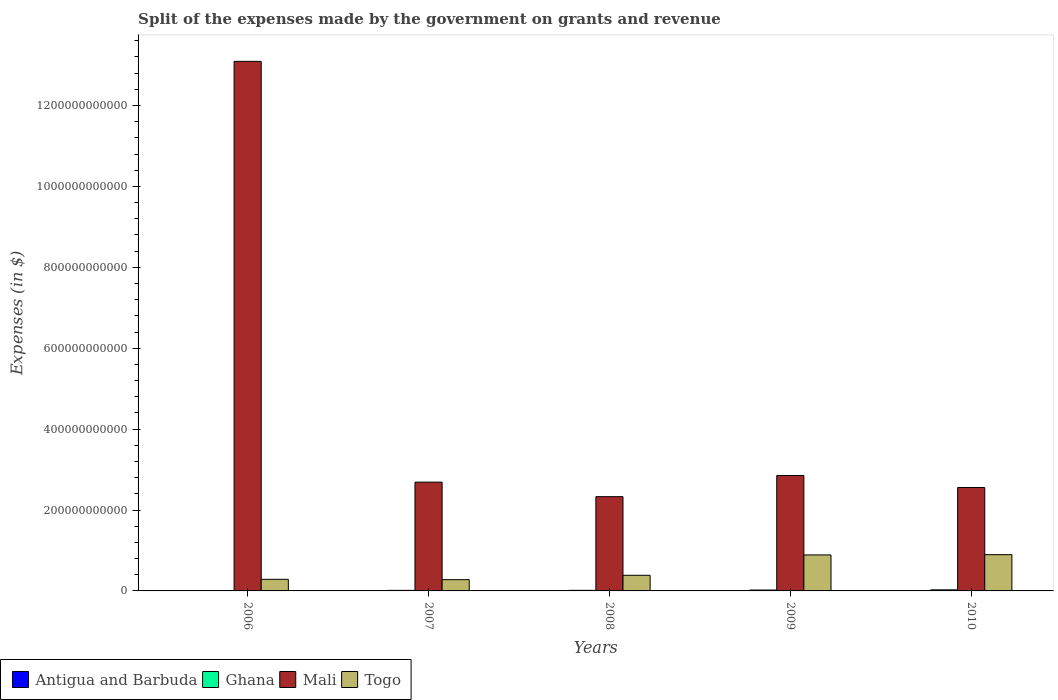Are the number of bars on each tick of the X-axis equal?
Provide a succinct answer. Yes. What is the label of the 3rd group of bars from the left?
Keep it short and to the point. 2008. In how many cases, is the number of bars for a given year not equal to the number of legend labels?
Provide a short and direct response. 0. What is the expenses made by the government on grants and revenue in Mali in 2006?
Your answer should be very brief. 1.31e+12. Across all years, what is the maximum expenses made by the government on grants and revenue in Antigua and Barbuda?
Your answer should be very brief. 1.10e+08. Across all years, what is the minimum expenses made by the government on grants and revenue in Ghana?
Make the answer very short. 8.75e+08. In which year was the expenses made by the government on grants and revenue in Mali maximum?
Provide a short and direct response. 2006. In which year was the expenses made by the government on grants and revenue in Ghana minimum?
Ensure brevity in your answer.  2006. What is the total expenses made by the government on grants and revenue in Ghana in the graph?
Provide a succinct answer. 8.56e+09. What is the difference between the expenses made by the government on grants and revenue in Mali in 2006 and that in 2007?
Make the answer very short. 1.04e+12. What is the difference between the expenses made by the government on grants and revenue in Antigua and Barbuda in 2010 and the expenses made by the government on grants and revenue in Ghana in 2006?
Your answer should be very brief. -7.67e+08. What is the average expenses made by the government on grants and revenue in Ghana per year?
Ensure brevity in your answer.  1.71e+09. In the year 2010, what is the difference between the expenses made by the government on grants and revenue in Ghana and expenses made by the government on grants and revenue in Antigua and Barbuda?
Keep it short and to the point. 2.59e+09. What is the ratio of the expenses made by the government on grants and revenue in Ghana in 2008 to that in 2010?
Keep it short and to the point. 0.53. Is the difference between the expenses made by the government on grants and revenue in Ghana in 2006 and 2010 greater than the difference between the expenses made by the government on grants and revenue in Antigua and Barbuda in 2006 and 2010?
Keep it short and to the point. No. What is the difference between the highest and the second highest expenses made by the government on grants and revenue in Antigua and Barbuda?
Give a very brief answer. 2.40e+06. What is the difference between the highest and the lowest expenses made by the government on grants and revenue in Ghana?
Your answer should be compact. 1.82e+09. Is the sum of the expenses made by the government on grants and revenue in Togo in 2008 and 2010 greater than the maximum expenses made by the government on grants and revenue in Ghana across all years?
Your answer should be compact. Yes. Is it the case that in every year, the sum of the expenses made by the government on grants and revenue in Ghana and expenses made by the government on grants and revenue in Antigua and Barbuda is greater than the sum of expenses made by the government on grants and revenue in Mali and expenses made by the government on grants and revenue in Togo?
Provide a succinct answer. Yes. What does the 3rd bar from the left in 2006 represents?
Your answer should be compact. Mali. What does the 4th bar from the right in 2010 represents?
Provide a short and direct response. Antigua and Barbuda. Is it the case that in every year, the sum of the expenses made by the government on grants and revenue in Togo and expenses made by the government on grants and revenue in Ghana is greater than the expenses made by the government on grants and revenue in Antigua and Barbuda?
Give a very brief answer. Yes. How many bars are there?
Keep it short and to the point. 20. How many years are there in the graph?
Provide a succinct answer. 5. What is the difference between two consecutive major ticks on the Y-axis?
Keep it short and to the point. 2.00e+11. Does the graph contain any zero values?
Your answer should be compact. No. Where does the legend appear in the graph?
Provide a short and direct response. Bottom left. How are the legend labels stacked?
Your response must be concise. Horizontal. What is the title of the graph?
Provide a succinct answer. Split of the expenses made by the government on grants and revenue. What is the label or title of the Y-axis?
Give a very brief answer. Expenses (in $). What is the Expenses (in $) of Antigua and Barbuda in 2006?
Offer a terse response. 1.10e+08. What is the Expenses (in $) of Ghana in 2006?
Offer a very short reply. 8.75e+08. What is the Expenses (in $) in Mali in 2006?
Your answer should be very brief. 1.31e+12. What is the Expenses (in $) in Togo in 2006?
Keep it short and to the point. 2.87e+1. What is the Expenses (in $) of Antigua and Barbuda in 2007?
Your answer should be very brief. 5.38e+07. What is the Expenses (in $) of Ghana in 2007?
Offer a terse response. 1.36e+09. What is the Expenses (in $) of Mali in 2007?
Make the answer very short. 2.69e+11. What is the Expenses (in $) of Togo in 2007?
Your answer should be compact. 2.78e+1. What is the Expenses (in $) in Antigua and Barbuda in 2008?
Provide a succinct answer. 7.36e+07. What is the Expenses (in $) of Ghana in 2008?
Provide a succinct answer. 1.44e+09. What is the Expenses (in $) in Mali in 2008?
Offer a very short reply. 2.33e+11. What is the Expenses (in $) in Togo in 2008?
Offer a terse response. 3.87e+1. What is the Expenses (in $) of Antigua and Barbuda in 2009?
Provide a succinct answer. 2.25e+07. What is the Expenses (in $) in Ghana in 2009?
Give a very brief answer. 2.19e+09. What is the Expenses (in $) in Mali in 2009?
Your response must be concise. 2.85e+11. What is the Expenses (in $) of Togo in 2009?
Your answer should be very brief. 8.90e+1. What is the Expenses (in $) in Antigua and Barbuda in 2010?
Make the answer very short. 1.08e+08. What is the Expenses (in $) of Ghana in 2010?
Provide a succinct answer. 2.69e+09. What is the Expenses (in $) in Mali in 2010?
Your answer should be compact. 2.56e+11. What is the Expenses (in $) of Togo in 2010?
Keep it short and to the point. 8.96e+1. Across all years, what is the maximum Expenses (in $) in Antigua and Barbuda?
Keep it short and to the point. 1.10e+08. Across all years, what is the maximum Expenses (in $) of Ghana?
Offer a very short reply. 2.69e+09. Across all years, what is the maximum Expenses (in $) of Mali?
Give a very brief answer. 1.31e+12. Across all years, what is the maximum Expenses (in $) of Togo?
Your response must be concise. 8.96e+1. Across all years, what is the minimum Expenses (in $) of Antigua and Barbuda?
Provide a short and direct response. 2.25e+07. Across all years, what is the minimum Expenses (in $) in Ghana?
Keep it short and to the point. 8.75e+08. Across all years, what is the minimum Expenses (in $) in Mali?
Your answer should be very brief. 2.33e+11. Across all years, what is the minimum Expenses (in $) in Togo?
Your answer should be very brief. 2.78e+1. What is the total Expenses (in $) of Antigua and Barbuda in the graph?
Provide a succinct answer. 3.68e+08. What is the total Expenses (in $) of Ghana in the graph?
Offer a very short reply. 8.56e+09. What is the total Expenses (in $) in Mali in the graph?
Offer a terse response. 2.35e+12. What is the total Expenses (in $) in Togo in the graph?
Provide a short and direct response. 2.74e+11. What is the difference between the Expenses (in $) of Antigua and Barbuda in 2006 and that in 2007?
Provide a short and direct response. 5.66e+07. What is the difference between the Expenses (in $) in Ghana in 2006 and that in 2007?
Make the answer very short. -4.88e+08. What is the difference between the Expenses (in $) of Mali in 2006 and that in 2007?
Offer a terse response. 1.04e+12. What is the difference between the Expenses (in $) of Togo in 2006 and that in 2007?
Offer a terse response. 8.62e+08. What is the difference between the Expenses (in $) in Antigua and Barbuda in 2006 and that in 2008?
Offer a terse response. 3.68e+07. What is the difference between the Expenses (in $) in Ghana in 2006 and that in 2008?
Give a very brief answer. -5.66e+08. What is the difference between the Expenses (in $) of Mali in 2006 and that in 2008?
Your response must be concise. 1.08e+12. What is the difference between the Expenses (in $) of Togo in 2006 and that in 2008?
Your response must be concise. -9.99e+09. What is the difference between the Expenses (in $) of Antigua and Barbuda in 2006 and that in 2009?
Your answer should be compact. 8.79e+07. What is the difference between the Expenses (in $) in Ghana in 2006 and that in 2009?
Provide a short and direct response. -1.31e+09. What is the difference between the Expenses (in $) in Mali in 2006 and that in 2009?
Ensure brevity in your answer.  1.02e+12. What is the difference between the Expenses (in $) of Togo in 2006 and that in 2009?
Provide a succinct answer. -6.03e+1. What is the difference between the Expenses (in $) of Antigua and Barbuda in 2006 and that in 2010?
Ensure brevity in your answer.  2.40e+06. What is the difference between the Expenses (in $) in Ghana in 2006 and that in 2010?
Your answer should be very brief. -1.82e+09. What is the difference between the Expenses (in $) in Mali in 2006 and that in 2010?
Your answer should be compact. 1.05e+12. What is the difference between the Expenses (in $) in Togo in 2006 and that in 2010?
Your answer should be compact. -6.09e+1. What is the difference between the Expenses (in $) in Antigua and Barbuda in 2007 and that in 2008?
Give a very brief answer. -1.98e+07. What is the difference between the Expenses (in $) in Ghana in 2007 and that in 2008?
Your response must be concise. -7.78e+07. What is the difference between the Expenses (in $) of Mali in 2007 and that in 2008?
Make the answer very short. 3.59e+1. What is the difference between the Expenses (in $) in Togo in 2007 and that in 2008?
Your answer should be compact. -1.08e+1. What is the difference between the Expenses (in $) in Antigua and Barbuda in 2007 and that in 2009?
Offer a terse response. 3.13e+07. What is the difference between the Expenses (in $) of Ghana in 2007 and that in 2009?
Offer a very short reply. -8.24e+08. What is the difference between the Expenses (in $) in Mali in 2007 and that in 2009?
Offer a terse response. -1.63e+1. What is the difference between the Expenses (in $) in Togo in 2007 and that in 2009?
Make the answer very short. -6.11e+1. What is the difference between the Expenses (in $) in Antigua and Barbuda in 2007 and that in 2010?
Keep it short and to the point. -5.42e+07. What is the difference between the Expenses (in $) of Ghana in 2007 and that in 2010?
Give a very brief answer. -1.33e+09. What is the difference between the Expenses (in $) of Mali in 2007 and that in 2010?
Give a very brief answer. 1.32e+1. What is the difference between the Expenses (in $) of Togo in 2007 and that in 2010?
Offer a very short reply. -6.18e+1. What is the difference between the Expenses (in $) in Antigua and Barbuda in 2008 and that in 2009?
Provide a short and direct response. 5.11e+07. What is the difference between the Expenses (in $) in Ghana in 2008 and that in 2009?
Offer a very short reply. -7.46e+08. What is the difference between the Expenses (in $) in Mali in 2008 and that in 2009?
Offer a very short reply. -5.23e+1. What is the difference between the Expenses (in $) in Togo in 2008 and that in 2009?
Keep it short and to the point. -5.03e+1. What is the difference between the Expenses (in $) of Antigua and Barbuda in 2008 and that in 2010?
Your response must be concise. -3.44e+07. What is the difference between the Expenses (in $) of Ghana in 2008 and that in 2010?
Your answer should be compact. -1.25e+09. What is the difference between the Expenses (in $) of Mali in 2008 and that in 2010?
Offer a terse response. -2.27e+1. What is the difference between the Expenses (in $) in Togo in 2008 and that in 2010?
Offer a terse response. -5.10e+1. What is the difference between the Expenses (in $) in Antigua and Barbuda in 2009 and that in 2010?
Keep it short and to the point. -8.55e+07. What is the difference between the Expenses (in $) in Ghana in 2009 and that in 2010?
Offer a very short reply. -5.08e+08. What is the difference between the Expenses (in $) in Mali in 2009 and that in 2010?
Keep it short and to the point. 2.96e+1. What is the difference between the Expenses (in $) of Togo in 2009 and that in 2010?
Ensure brevity in your answer.  -6.60e+08. What is the difference between the Expenses (in $) in Antigua and Barbuda in 2006 and the Expenses (in $) in Ghana in 2007?
Your answer should be very brief. -1.25e+09. What is the difference between the Expenses (in $) of Antigua and Barbuda in 2006 and the Expenses (in $) of Mali in 2007?
Your response must be concise. -2.69e+11. What is the difference between the Expenses (in $) in Antigua and Barbuda in 2006 and the Expenses (in $) in Togo in 2007?
Provide a succinct answer. -2.77e+1. What is the difference between the Expenses (in $) in Ghana in 2006 and the Expenses (in $) in Mali in 2007?
Offer a very short reply. -2.68e+11. What is the difference between the Expenses (in $) of Ghana in 2006 and the Expenses (in $) of Togo in 2007?
Keep it short and to the point. -2.69e+1. What is the difference between the Expenses (in $) of Mali in 2006 and the Expenses (in $) of Togo in 2007?
Your answer should be very brief. 1.28e+12. What is the difference between the Expenses (in $) in Antigua and Barbuda in 2006 and the Expenses (in $) in Ghana in 2008?
Offer a terse response. -1.33e+09. What is the difference between the Expenses (in $) of Antigua and Barbuda in 2006 and the Expenses (in $) of Mali in 2008?
Give a very brief answer. -2.33e+11. What is the difference between the Expenses (in $) in Antigua and Barbuda in 2006 and the Expenses (in $) in Togo in 2008?
Give a very brief answer. -3.85e+1. What is the difference between the Expenses (in $) of Ghana in 2006 and the Expenses (in $) of Mali in 2008?
Your answer should be very brief. -2.32e+11. What is the difference between the Expenses (in $) in Ghana in 2006 and the Expenses (in $) in Togo in 2008?
Your answer should be compact. -3.78e+1. What is the difference between the Expenses (in $) of Mali in 2006 and the Expenses (in $) of Togo in 2008?
Offer a terse response. 1.27e+12. What is the difference between the Expenses (in $) of Antigua and Barbuda in 2006 and the Expenses (in $) of Ghana in 2009?
Offer a terse response. -2.08e+09. What is the difference between the Expenses (in $) of Antigua and Barbuda in 2006 and the Expenses (in $) of Mali in 2009?
Give a very brief answer. -2.85e+11. What is the difference between the Expenses (in $) in Antigua and Barbuda in 2006 and the Expenses (in $) in Togo in 2009?
Your answer should be very brief. -8.88e+1. What is the difference between the Expenses (in $) of Ghana in 2006 and the Expenses (in $) of Mali in 2009?
Ensure brevity in your answer.  -2.84e+11. What is the difference between the Expenses (in $) in Ghana in 2006 and the Expenses (in $) in Togo in 2009?
Make the answer very short. -8.81e+1. What is the difference between the Expenses (in $) in Mali in 2006 and the Expenses (in $) in Togo in 2009?
Provide a succinct answer. 1.22e+12. What is the difference between the Expenses (in $) of Antigua and Barbuda in 2006 and the Expenses (in $) of Ghana in 2010?
Your answer should be compact. -2.58e+09. What is the difference between the Expenses (in $) of Antigua and Barbuda in 2006 and the Expenses (in $) of Mali in 2010?
Provide a succinct answer. -2.56e+11. What is the difference between the Expenses (in $) of Antigua and Barbuda in 2006 and the Expenses (in $) of Togo in 2010?
Offer a very short reply. -8.95e+1. What is the difference between the Expenses (in $) in Ghana in 2006 and the Expenses (in $) in Mali in 2010?
Your response must be concise. -2.55e+11. What is the difference between the Expenses (in $) of Ghana in 2006 and the Expenses (in $) of Togo in 2010?
Give a very brief answer. -8.87e+1. What is the difference between the Expenses (in $) in Mali in 2006 and the Expenses (in $) in Togo in 2010?
Offer a very short reply. 1.22e+12. What is the difference between the Expenses (in $) of Antigua and Barbuda in 2007 and the Expenses (in $) of Ghana in 2008?
Ensure brevity in your answer.  -1.39e+09. What is the difference between the Expenses (in $) in Antigua and Barbuda in 2007 and the Expenses (in $) in Mali in 2008?
Provide a succinct answer. -2.33e+11. What is the difference between the Expenses (in $) of Antigua and Barbuda in 2007 and the Expenses (in $) of Togo in 2008?
Your answer should be very brief. -3.86e+1. What is the difference between the Expenses (in $) in Ghana in 2007 and the Expenses (in $) in Mali in 2008?
Ensure brevity in your answer.  -2.32e+11. What is the difference between the Expenses (in $) in Ghana in 2007 and the Expenses (in $) in Togo in 2008?
Your response must be concise. -3.73e+1. What is the difference between the Expenses (in $) in Mali in 2007 and the Expenses (in $) in Togo in 2008?
Keep it short and to the point. 2.30e+11. What is the difference between the Expenses (in $) in Antigua and Barbuda in 2007 and the Expenses (in $) in Ghana in 2009?
Offer a terse response. -2.13e+09. What is the difference between the Expenses (in $) in Antigua and Barbuda in 2007 and the Expenses (in $) in Mali in 2009?
Your answer should be compact. -2.85e+11. What is the difference between the Expenses (in $) in Antigua and Barbuda in 2007 and the Expenses (in $) in Togo in 2009?
Your response must be concise. -8.89e+1. What is the difference between the Expenses (in $) of Ghana in 2007 and the Expenses (in $) of Mali in 2009?
Ensure brevity in your answer.  -2.84e+11. What is the difference between the Expenses (in $) of Ghana in 2007 and the Expenses (in $) of Togo in 2009?
Make the answer very short. -8.76e+1. What is the difference between the Expenses (in $) of Mali in 2007 and the Expenses (in $) of Togo in 2009?
Provide a short and direct response. 1.80e+11. What is the difference between the Expenses (in $) of Antigua and Barbuda in 2007 and the Expenses (in $) of Ghana in 2010?
Provide a succinct answer. -2.64e+09. What is the difference between the Expenses (in $) of Antigua and Barbuda in 2007 and the Expenses (in $) of Mali in 2010?
Provide a short and direct response. -2.56e+11. What is the difference between the Expenses (in $) of Antigua and Barbuda in 2007 and the Expenses (in $) of Togo in 2010?
Make the answer very short. -8.96e+1. What is the difference between the Expenses (in $) of Ghana in 2007 and the Expenses (in $) of Mali in 2010?
Make the answer very short. -2.54e+11. What is the difference between the Expenses (in $) of Ghana in 2007 and the Expenses (in $) of Togo in 2010?
Offer a terse response. -8.82e+1. What is the difference between the Expenses (in $) of Mali in 2007 and the Expenses (in $) of Togo in 2010?
Offer a very short reply. 1.79e+11. What is the difference between the Expenses (in $) of Antigua and Barbuda in 2008 and the Expenses (in $) of Ghana in 2009?
Offer a terse response. -2.11e+09. What is the difference between the Expenses (in $) in Antigua and Barbuda in 2008 and the Expenses (in $) in Mali in 2009?
Ensure brevity in your answer.  -2.85e+11. What is the difference between the Expenses (in $) of Antigua and Barbuda in 2008 and the Expenses (in $) of Togo in 2009?
Provide a short and direct response. -8.89e+1. What is the difference between the Expenses (in $) of Ghana in 2008 and the Expenses (in $) of Mali in 2009?
Your response must be concise. -2.84e+11. What is the difference between the Expenses (in $) in Ghana in 2008 and the Expenses (in $) in Togo in 2009?
Offer a very short reply. -8.75e+1. What is the difference between the Expenses (in $) of Mali in 2008 and the Expenses (in $) of Togo in 2009?
Provide a succinct answer. 1.44e+11. What is the difference between the Expenses (in $) in Antigua and Barbuda in 2008 and the Expenses (in $) in Ghana in 2010?
Your answer should be compact. -2.62e+09. What is the difference between the Expenses (in $) of Antigua and Barbuda in 2008 and the Expenses (in $) of Mali in 2010?
Your response must be concise. -2.56e+11. What is the difference between the Expenses (in $) of Antigua and Barbuda in 2008 and the Expenses (in $) of Togo in 2010?
Your response must be concise. -8.95e+1. What is the difference between the Expenses (in $) in Ghana in 2008 and the Expenses (in $) in Mali in 2010?
Give a very brief answer. -2.54e+11. What is the difference between the Expenses (in $) of Ghana in 2008 and the Expenses (in $) of Togo in 2010?
Give a very brief answer. -8.82e+1. What is the difference between the Expenses (in $) of Mali in 2008 and the Expenses (in $) of Togo in 2010?
Make the answer very short. 1.43e+11. What is the difference between the Expenses (in $) of Antigua and Barbuda in 2009 and the Expenses (in $) of Ghana in 2010?
Ensure brevity in your answer.  -2.67e+09. What is the difference between the Expenses (in $) of Antigua and Barbuda in 2009 and the Expenses (in $) of Mali in 2010?
Your answer should be compact. -2.56e+11. What is the difference between the Expenses (in $) in Antigua and Barbuda in 2009 and the Expenses (in $) in Togo in 2010?
Ensure brevity in your answer.  -8.96e+1. What is the difference between the Expenses (in $) of Ghana in 2009 and the Expenses (in $) of Mali in 2010?
Provide a succinct answer. -2.53e+11. What is the difference between the Expenses (in $) in Ghana in 2009 and the Expenses (in $) in Togo in 2010?
Provide a succinct answer. -8.74e+1. What is the difference between the Expenses (in $) in Mali in 2009 and the Expenses (in $) in Togo in 2010?
Give a very brief answer. 1.96e+11. What is the average Expenses (in $) in Antigua and Barbuda per year?
Provide a short and direct response. 7.37e+07. What is the average Expenses (in $) in Ghana per year?
Keep it short and to the point. 1.71e+09. What is the average Expenses (in $) in Mali per year?
Make the answer very short. 4.70e+11. What is the average Expenses (in $) of Togo per year?
Provide a short and direct response. 5.47e+1. In the year 2006, what is the difference between the Expenses (in $) of Antigua and Barbuda and Expenses (in $) of Ghana?
Your answer should be compact. -7.64e+08. In the year 2006, what is the difference between the Expenses (in $) of Antigua and Barbuda and Expenses (in $) of Mali?
Your answer should be very brief. -1.31e+12. In the year 2006, what is the difference between the Expenses (in $) in Antigua and Barbuda and Expenses (in $) in Togo?
Make the answer very short. -2.86e+1. In the year 2006, what is the difference between the Expenses (in $) in Ghana and Expenses (in $) in Mali?
Ensure brevity in your answer.  -1.31e+12. In the year 2006, what is the difference between the Expenses (in $) of Ghana and Expenses (in $) of Togo?
Offer a very short reply. -2.78e+1. In the year 2006, what is the difference between the Expenses (in $) in Mali and Expenses (in $) in Togo?
Give a very brief answer. 1.28e+12. In the year 2007, what is the difference between the Expenses (in $) of Antigua and Barbuda and Expenses (in $) of Ghana?
Your response must be concise. -1.31e+09. In the year 2007, what is the difference between the Expenses (in $) of Antigua and Barbuda and Expenses (in $) of Mali?
Give a very brief answer. -2.69e+11. In the year 2007, what is the difference between the Expenses (in $) in Antigua and Barbuda and Expenses (in $) in Togo?
Provide a succinct answer. -2.78e+1. In the year 2007, what is the difference between the Expenses (in $) of Ghana and Expenses (in $) of Mali?
Provide a succinct answer. -2.68e+11. In the year 2007, what is the difference between the Expenses (in $) in Ghana and Expenses (in $) in Togo?
Give a very brief answer. -2.64e+1. In the year 2007, what is the difference between the Expenses (in $) of Mali and Expenses (in $) of Togo?
Your answer should be compact. 2.41e+11. In the year 2008, what is the difference between the Expenses (in $) in Antigua and Barbuda and Expenses (in $) in Ghana?
Your answer should be compact. -1.37e+09. In the year 2008, what is the difference between the Expenses (in $) of Antigua and Barbuda and Expenses (in $) of Mali?
Provide a short and direct response. -2.33e+11. In the year 2008, what is the difference between the Expenses (in $) of Antigua and Barbuda and Expenses (in $) of Togo?
Provide a succinct answer. -3.86e+1. In the year 2008, what is the difference between the Expenses (in $) in Ghana and Expenses (in $) in Mali?
Keep it short and to the point. -2.32e+11. In the year 2008, what is the difference between the Expenses (in $) of Ghana and Expenses (in $) of Togo?
Your answer should be very brief. -3.72e+1. In the year 2008, what is the difference between the Expenses (in $) of Mali and Expenses (in $) of Togo?
Your answer should be very brief. 1.94e+11. In the year 2009, what is the difference between the Expenses (in $) in Antigua and Barbuda and Expenses (in $) in Ghana?
Provide a short and direct response. -2.16e+09. In the year 2009, what is the difference between the Expenses (in $) in Antigua and Barbuda and Expenses (in $) in Mali?
Make the answer very short. -2.85e+11. In the year 2009, what is the difference between the Expenses (in $) of Antigua and Barbuda and Expenses (in $) of Togo?
Provide a succinct answer. -8.89e+1. In the year 2009, what is the difference between the Expenses (in $) of Ghana and Expenses (in $) of Mali?
Make the answer very short. -2.83e+11. In the year 2009, what is the difference between the Expenses (in $) of Ghana and Expenses (in $) of Togo?
Your answer should be very brief. -8.68e+1. In the year 2009, what is the difference between the Expenses (in $) in Mali and Expenses (in $) in Togo?
Your response must be concise. 1.96e+11. In the year 2010, what is the difference between the Expenses (in $) of Antigua and Barbuda and Expenses (in $) of Ghana?
Keep it short and to the point. -2.59e+09. In the year 2010, what is the difference between the Expenses (in $) of Antigua and Barbuda and Expenses (in $) of Mali?
Ensure brevity in your answer.  -2.56e+11. In the year 2010, what is the difference between the Expenses (in $) of Antigua and Barbuda and Expenses (in $) of Togo?
Your answer should be very brief. -8.95e+1. In the year 2010, what is the difference between the Expenses (in $) of Ghana and Expenses (in $) of Mali?
Provide a short and direct response. -2.53e+11. In the year 2010, what is the difference between the Expenses (in $) of Ghana and Expenses (in $) of Togo?
Ensure brevity in your answer.  -8.69e+1. In the year 2010, what is the difference between the Expenses (in $) of Mali and Expenses (in $) of Togo?
Give a very brief answer. 1.66e+11. What is the ratio of the Expenses (in $) in Antigua and Barbuda in 2006 to that in 2007?
Your response must be concise. 2.05. What is the ratio of the Expenses (in $) of Ghana in 2006 to that in 2007?
Make the answer very short. 0.64. What is the ratio of the Expenses (in $) in Mali in 2006 to that in 2007?
Your answer should be very brief. 4.87. What is the ratio of the Expenses (in $) of Togo in 2006 to that in 2007?
Your response must be concise. 1.03. What is the ratio of the Expenses (in $) in Ghana in 2006 to that in 2008?
Provide a short and direct response. 0.61. What is the ratio of the Expenses (in $) in Mali in 2006 to that in 2008?
Offer a terse response. 5.62. What is the ratio of the Expenses (in $) of Togo in 2006 to that in 2008?
Provide a succinct answer. 0.74. What is the ratio of the Expenses (in $) in Antigua and Barbuda in 2006 to that in 2009?
Make the answer very short. 4.91. What is the ratio of the Expenses (in $) of Mali in 2006 to that in 2009?
Ensure brevity in your answer.  4.59. What is the ratio of the Expenses (in $) of Togo in 2006 to that in 2009?
Provide a short and direct response. 0.32. What is the ratio of the Expenses (in $) in Antigua and Barbuda in 2006 to that in 2010?
Give a very brief answer. 1.02. What is the ratio of the Expenses (in $) of Ghana in 2006 to that in 2010?
Your answer should be very brief. 0.32. What is the ratio of the Expenses (in $) of Mali in 2006 to that in 2010?
Give a very brief answer. 5.12. What is the ratio of the Expenses (in $) in Togo in 2006 to that in 2010?
Your answer should be compact. 0.32. What is the ratio of the Expenses (in $) of Antigua and Barbuda in 2007 to that in 2008?
Ensure brevity in your answer.  0.73. What is the ratio of the Expenses (in $) of Ghana in 2007 to that in 2008?
Offer a very short reply. 0.95. What is the ratio of the Expenses (in $) of Mali in 2007 to that in 2008?
Your response must be concise. 1.15. What is the ratio of the Expenses (in $) of Togo in 2007 to that in 2008?
Provide a succinct answer. 0.72. What is the ratio of the Expenses (in $) in Antigua and Barbuda in 2007 to that in 2009?
Ensure brevity in your answer.  2.39. What is the ratio of the Expenses (in $) in Ghana in 2007 to that in 2009?
Offer a terse response. 0.62. What is the ratio of the Expenses (in $) in Mali in 2007 to that in 2009?
Your answer should be compact. 0.94. What is the ratio of the Expenses (in $) of Togo in 2007 to that in 2009?
Give a very brief answer. 0.31. What is the ratio of the Expenses (in $) of Antigua and Barbuda in 2007 to that in 2010?
Offer a terse response. 0.5. What is the ratio of the Expenses (in $) of Ghana in 2007 to that in 2010?
Offer a very short reply. 0.51. What is the ratio of the Expenses (in $) in Mali in 2007 to that in 2010?
Provide a short and direct response. 1.05. What is the ratio of the Expenses (in $) of Togo in 2007 to that in 2010?
Offer a terse response. 0.31. What is the ratio of the Expenses (in $) in Antigua and Barbuda in 2008 to that in 2009?
Offer a very short reply. 3.27. What is the ratio of the Expenses (in $) of Ghana in 2008 to that in 2009?
Offer a terse response. 0.66. What is the ratio of the Expenses (in $) in Mali in 2008 to that in 2009?
Provide a short and direct response. 0.82. What is the ratio of the Expenses (in $) in Togo in 2008 to that in 2009?
Offer a terse response. 0.43. What is the ratio of the Expenses (in $) in Antigua and Barbuda in 2008 to that in 2010?
Your answer should be compact. 0.68. What is the ratio of the Expenses (in $) of Ghana in 2008 to that in 2010?
Your response must be concise. 0.53. What is the ratio of the Expenses (in $) in Mali in 2008 to that in 2010?
Provide a succinct answer. 0.91. What is the ratio of the Expenses (in $) of Togo in 2008 to that in 2010?
Give a very brief answer. 0.43. What is the ratio of the Expenses (in $) in Antigua and Barbuda in 2009 to that in 2010?
Offer a terse response. 0.21. What is the ratio of the Expenses (in $) of Ghana in 2009 to that in 2010?
Offer a very short reply. 0.81. What is the ratio of the Expenses (in $) in Mali in 2009 to that in 2010?
Offer a terse response. 1.12. What is the ratio of the Expenses (in $) of Togo in 2009 to that in 2010?
Your response must be concise. 0.99. What is the difference between the highest and the second highest Expenses (in $) in Antigua and Barbuda?
Provide a succinct answer. 2.40e+06. What is the difference between the highest and the second highest Expenses (in $) of Ghana?
Provide a succinct answer. 5.08e+08. What is the difference between the highest and the second highest Expenses (in $) of Mali?
Provide a succinct answer. 1.02e+12. What is the difference between the highest and the second highest Expenses (in $) in Togo?
Give a very brief answer. 6.60e+08. What is the difference between the highest and the lowest Expenses (in $) in Antigua and Barbuda?
Make the answer very short. 8.79e+07. What is the difference between the highest and the lowest Expenses (in $) of Ghana?
Provide a short and direct response. 1.82e+09. What is the difference between the highest and the lowest Expenses (in $) in Mali?
Offer a very short reply. 1.08e+12. What is the difference between the highest and the lowest Expenses (in $) of Togo?
Your answer should be very brief. 6.18e+1. 